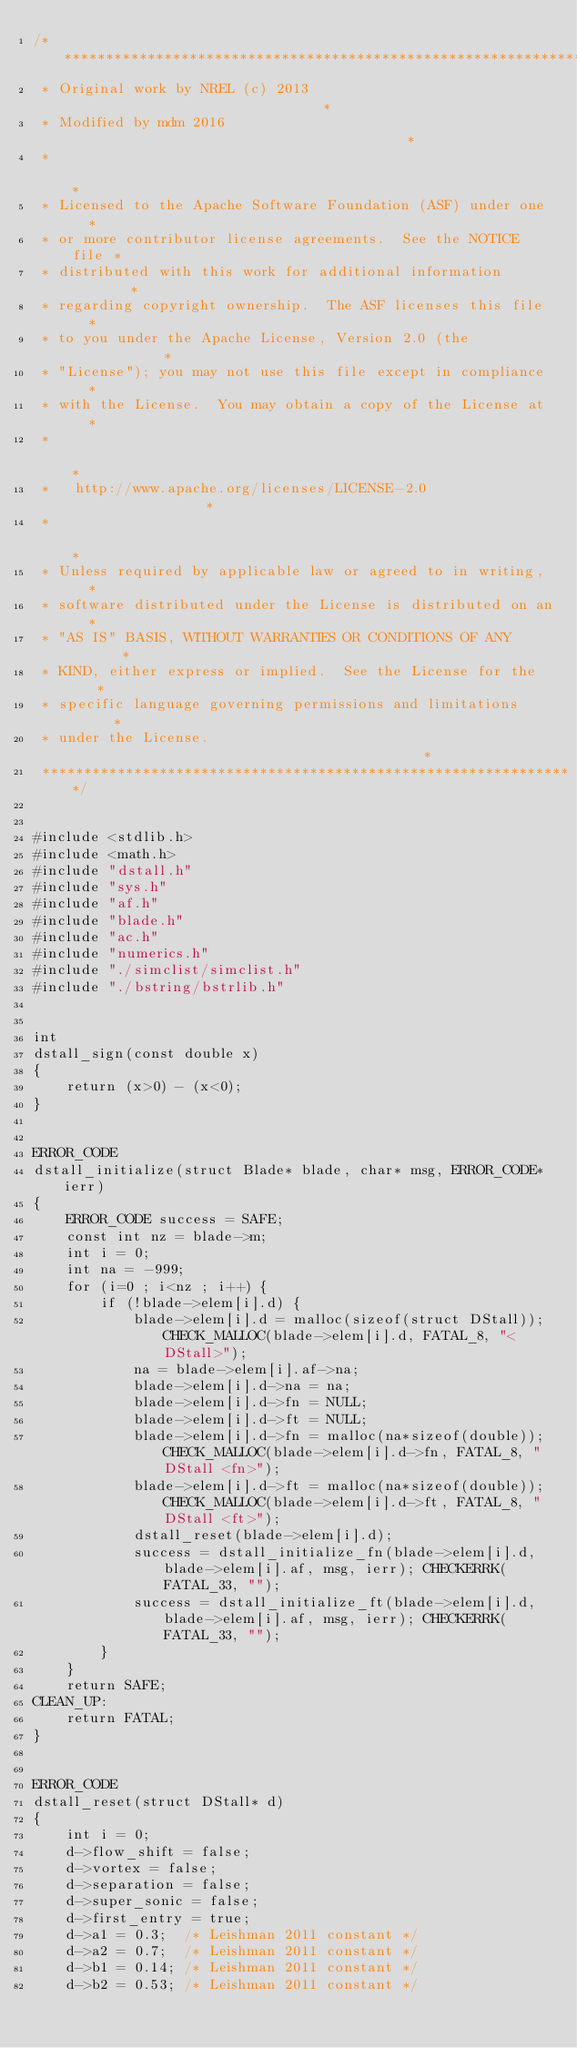Convert code to text. <code><loc_0><loc_0><loc_500><loc_500><_C_>/****************************************************************
 * Original work by NREL (c) 2013                               *
 * Modified by mdm 2016                                         *
 *                                                              *
 * Licensed to the Apache Software Foundation (ASF) under one   *
 * or more contributor license agreements.  See the NOTICE file *
 * distributed with this work for additional information        *
 * regarding copyright ownership.  The ASF licenses this file   *
 * to you under the Apache License, Version 2.0 (the            *
 * "License"); you may not use this file except in compliance   *
 * with the License.  You may obtain a copy of the License at   *
 *                                                              *
 *   http://www.apache.org/licenses/LICENSE-2.0                 *
 *                                                              *
 * Unless required by applicable law or agreed to in writing,   *
 * software distributed under the License is distributed on an  *
 * "AS IS" BASIS, WITHOUT WARRANTIES OR CONDITIONS OF ANY       *
 * KIND, either express or implied.  See the License for the    *
 * specific language governing permissions and limitations      *      
 * under the License.                                           *  
 ****************************************************************/


#include <stdlib.h>
#include <math.h>
#include "dstall.h"
#include "sys.h"
#include "af.h"
#include "blade.h"
#include "ac.h"
#include "numerics.h"
#include "./simclist/simclist.h"
#include "./bstring/bstrlib.h"


int
dstall_sign(const double x)
{
    return (x>0) - (x<0);
}


ERROR_CODE
dstall_initialize(struct Blade* blade, char* msg, ERROR_CODE* ierr)
{
    ERROR_CODE success = SAFE;
    const int nz = blade->m;
    int i = 0;
    int na = -999;
    for (i=0 ; i<nz ; i++) {
        if (!blade->elem[i].d) {
            blade->elem[i].d = malloc(sizeof(struct DStall)); CHECK_MALLOC(blade->elem[i].d, FATAL_8, "<DStall>");
            na = blade->elem[i].af->na;
            blade->elem[i].d->na = na;
            blade->elem[i].d->fn = NULL;   
            blade->elem[i].d->ft = NULL;
            blade->elem[i].d->fn = malloc(na*sizeof(double)); CHECK_MALLOC(blade->elem[i].d->fn, FATAL_8, "DStall <fn>");
            blade->elem[i].d->ft = malloc(na*sizeof(double)); CHECK_MALLOC(blade->elem[i].d->ft, FATAL_8, "DStall <ft>");
            dstall_reset(blade->elem[i].d);
            success = dstall_initialize_fn(blade->elem[i].d, blade->elem[i].af, msg, ierr); CHECKERRK(FATAL_33, "");
            success = dstall_initialize_ft(blade->elem[i].d, blade->elem[i].af, msg, ierr); CHECKERRK(FATAL_33, "");
        }
    }
    return SAFE;
CLEAN_UP:
    return FATAL;
}


ERROR_CODE
dstall_reset(struct DStall* d)
{
    int i = 0;
    d->flow_shift = false;
    d->vortex = false;
    d->separation = false;
    d->super_sonic = false;
    d->first_entry = true;
    d->a1 = 0.3;  /* Leishman 2011 constant */
    d->a2 = 0.7;  /* Leishman 2011 constant */
    d->b1 = 0.14; /* Leishman 2011 constant */
    d->b2 = 0.53; /* Leishman 2011 constant */</code> 